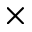<formula> <loc_0><loc_0><loc_500><loc_500>\times</formula> 